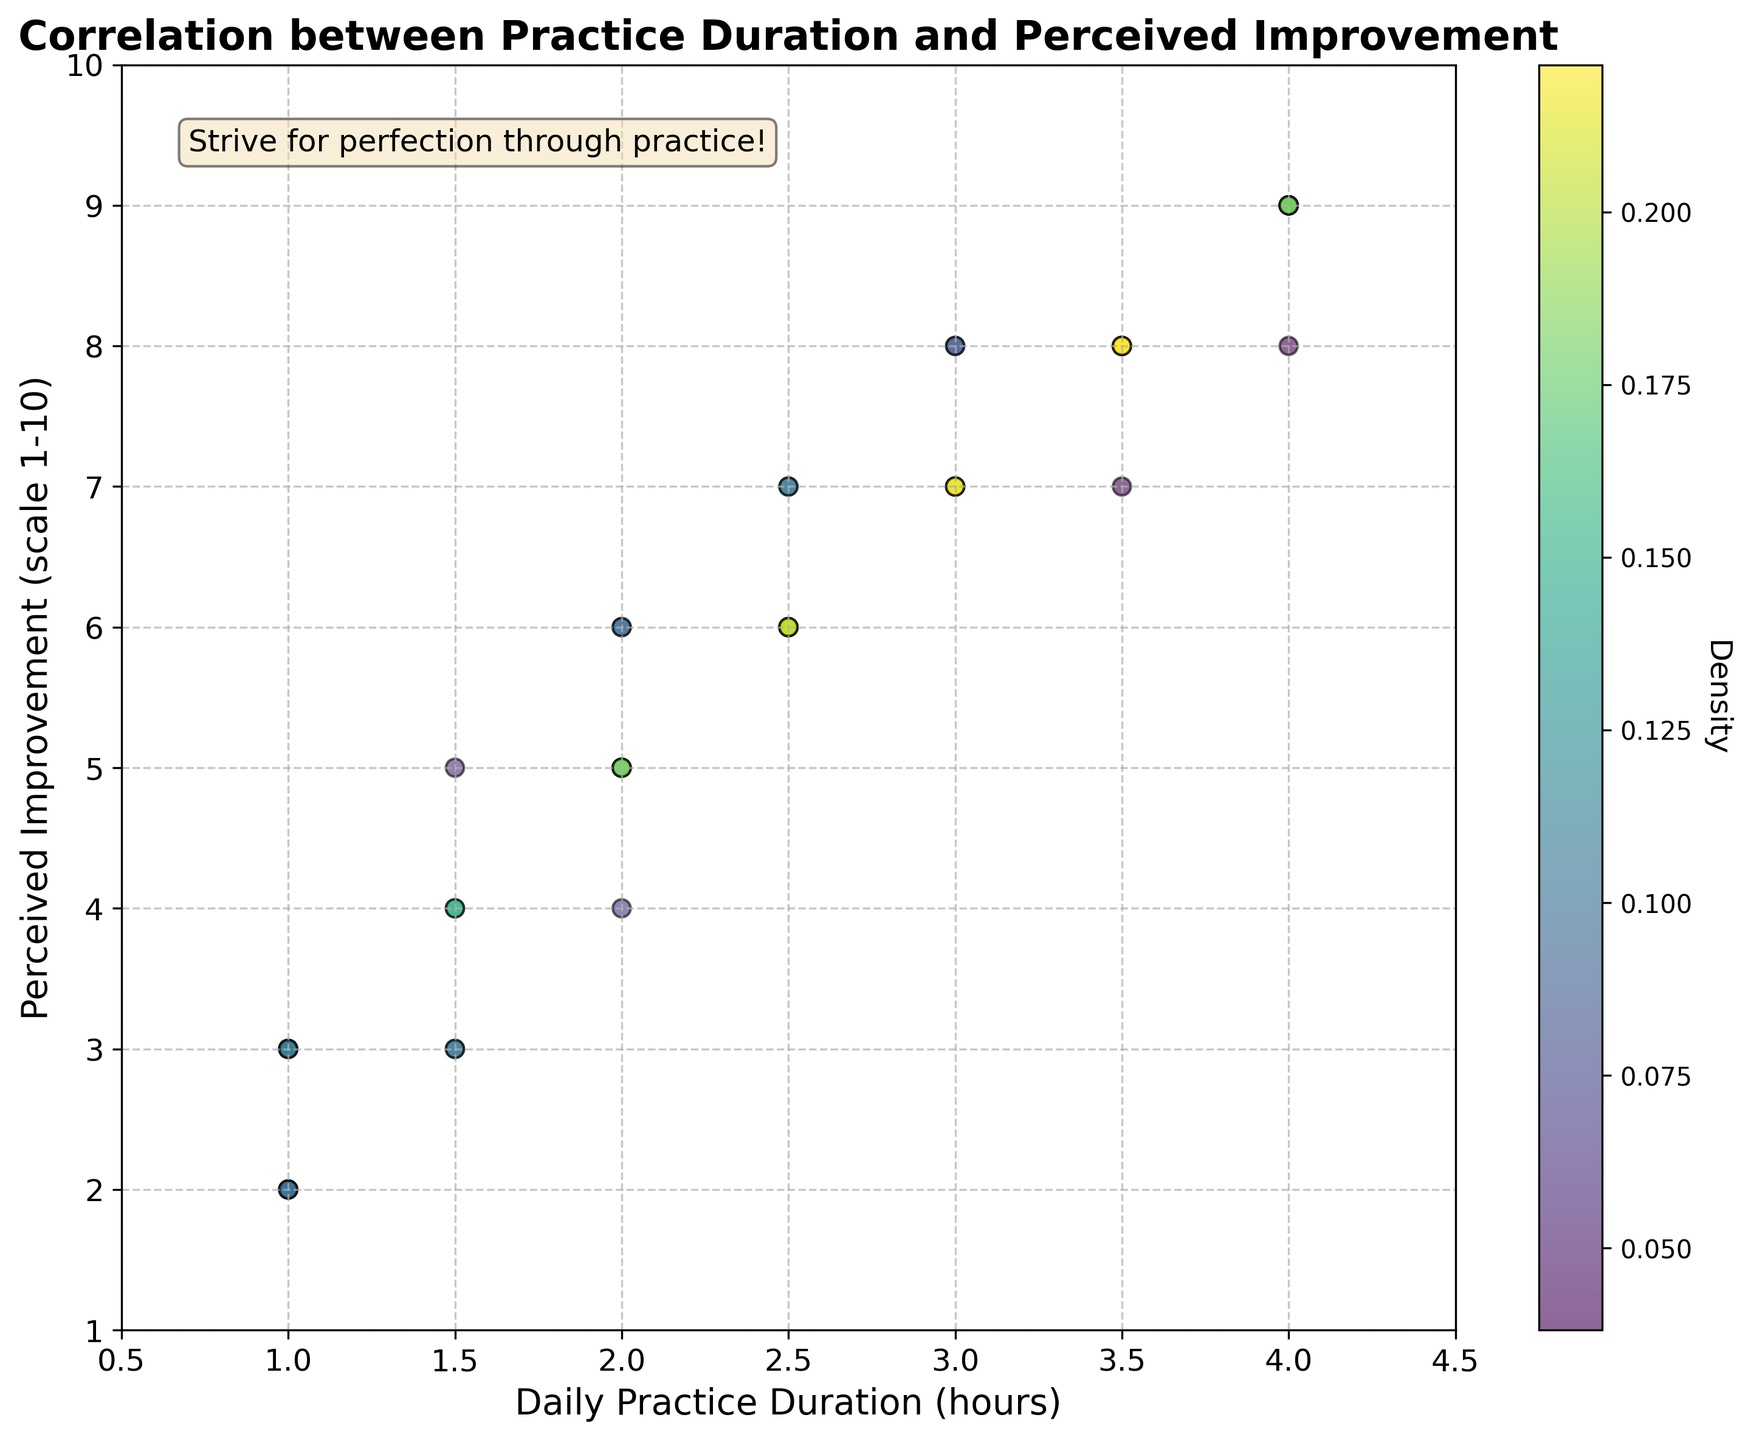What is the title of the plot? The title is usually placed at the top of the plot. In this case, the title is clearly labeled at the top.
Answer: Correlation between Practice Duration and Perceived Improvement What is the label for the x-axis? The x-axis label is typically displayed below the horizontal axis, explaining what data is plotted along this axis.
Answer: Daily Practice Duration (hours) What range does the y-axis cover? The y-axis range is identified by looking at the tick marks along the vertical axis from the lowest to the highest value.
Answer: 1 to 10 What does the color indicate in the scatter plot? The color represents the density at each data point, as explained by the color bar on the right side of the plot.
Answer: Density Is there a general trend visible between Daily Practice Duration and Perceived Improvement? Observing the scatter plot shows that as the practice duration increases, there is a corresponding increase in perceived improvement.
Answer: Yes, there is a positive correlation Which perceived improvement value has the highest density of points? The highest density value can be discerned by the darkest or most intense color in the plot, particularly around certain y-values.
Answer: 9 How many actors reported a practice duration of 4 hours? By looking at the x-axis at the 4-hour mark and counting the data points vertically, you can determine the number of actors.
Answer: 5 Which range of practice duration has the most scattered data points? By surveying the x-axis and observing where the dots are most dispersed, we can find that the range with the most scatter is around 2-3.5 hours.
Answer: 2 – 3.5 hours What is the perceived improvement for an actor practicing 3 hours daily? To find this, we look at the points aligned vertically above the 3-hour mark on the x-axis and check their y-values.
Answer: 7, 8 How does the perceived improvement vary for actors practicing 1 hour daily compared to those practicing 4 hours daily? For actors practicing 1 hour, the perceived improvement ranges from 2 to 5, whereas for those practicing 4 hours, it ranges from 8 to 9. This is visualized by observing the data points at the respective x-axis positions.
Answer: 2-5 for 1 hour, 8-9 for 4 hours 